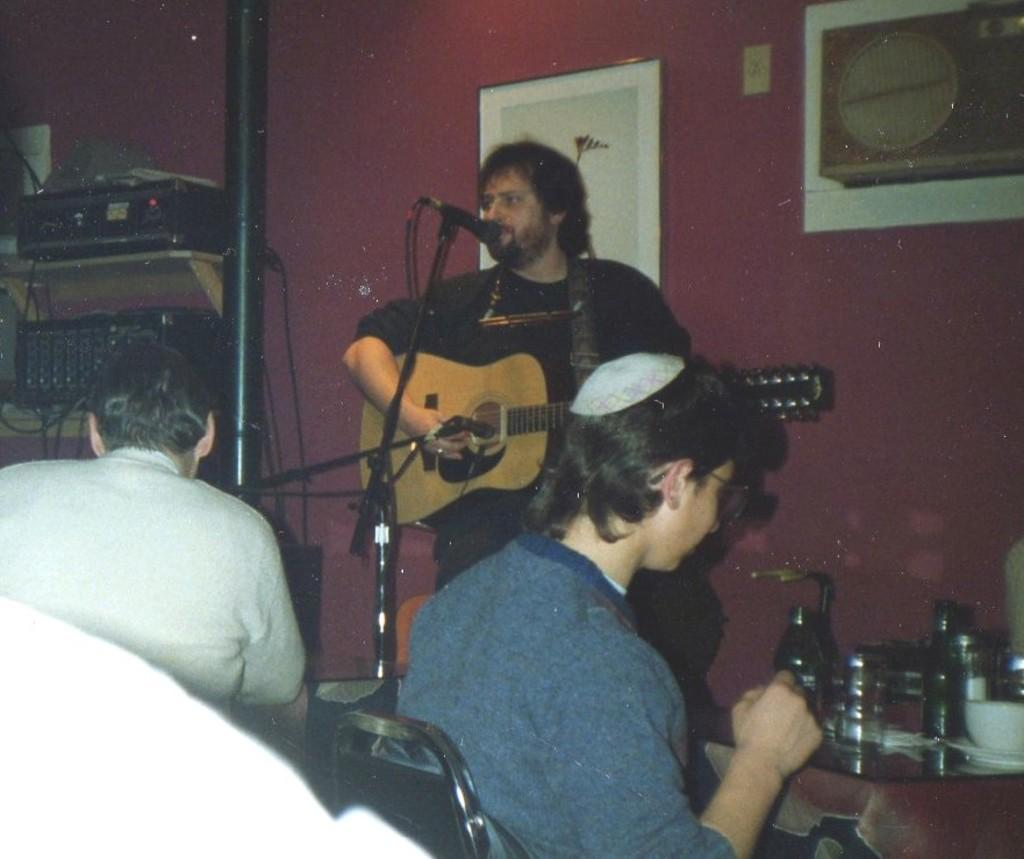How many men are in the image? There are three men in the image. What is one of the men doing? One of the men is playing a guitar. What else is the man playing the guitar doing? The man playing the guitar is also singing. How is the man singing connected to the guitar? The man singing is using a microphone. What can be found on the table in the image? There are jars on the table. What type of loaf is being served to the men in the image? There is no loaf present in the image. Is the prison mentioned or visible in the image? There is no mention or visual reference to a prison in the image. 